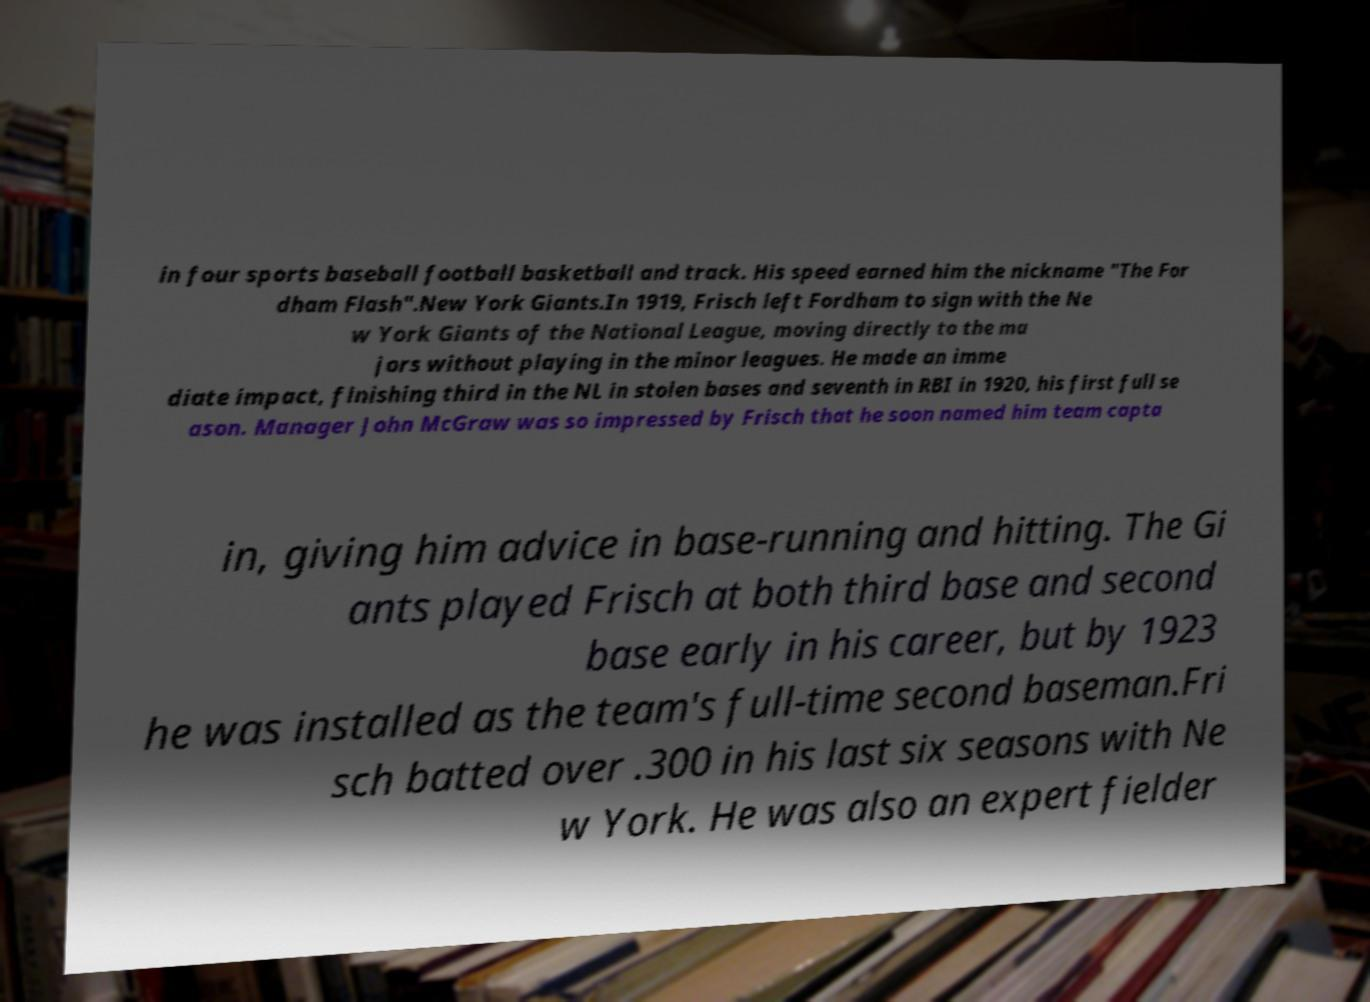Please read and relay the text visible in this image. What does it say? in four sports baseball football basketball and track. His speed earned him the nickname "The For dham Flash".New York Giants.In 1919, Frisch left Fordham to sign with the Ne w York Giants of the National League, moving directly to the ma jors without playing in the minor leagues. He made an imme diate impact, finishing third in the NL in stolen bases and seventh in RBI in 1920, his first full se ason. Manager John McGraw was so impressed by Frisch that he soon named him team capta in, giving him advice in base-running and hitting. The Gi ants played Frisch at both third base and second base early in his career, but by 1923 he was installed as the team's full-time second baseman.Fri sch batted over .300 in his last six seasons with Ne w York. He was also an expert fielder 